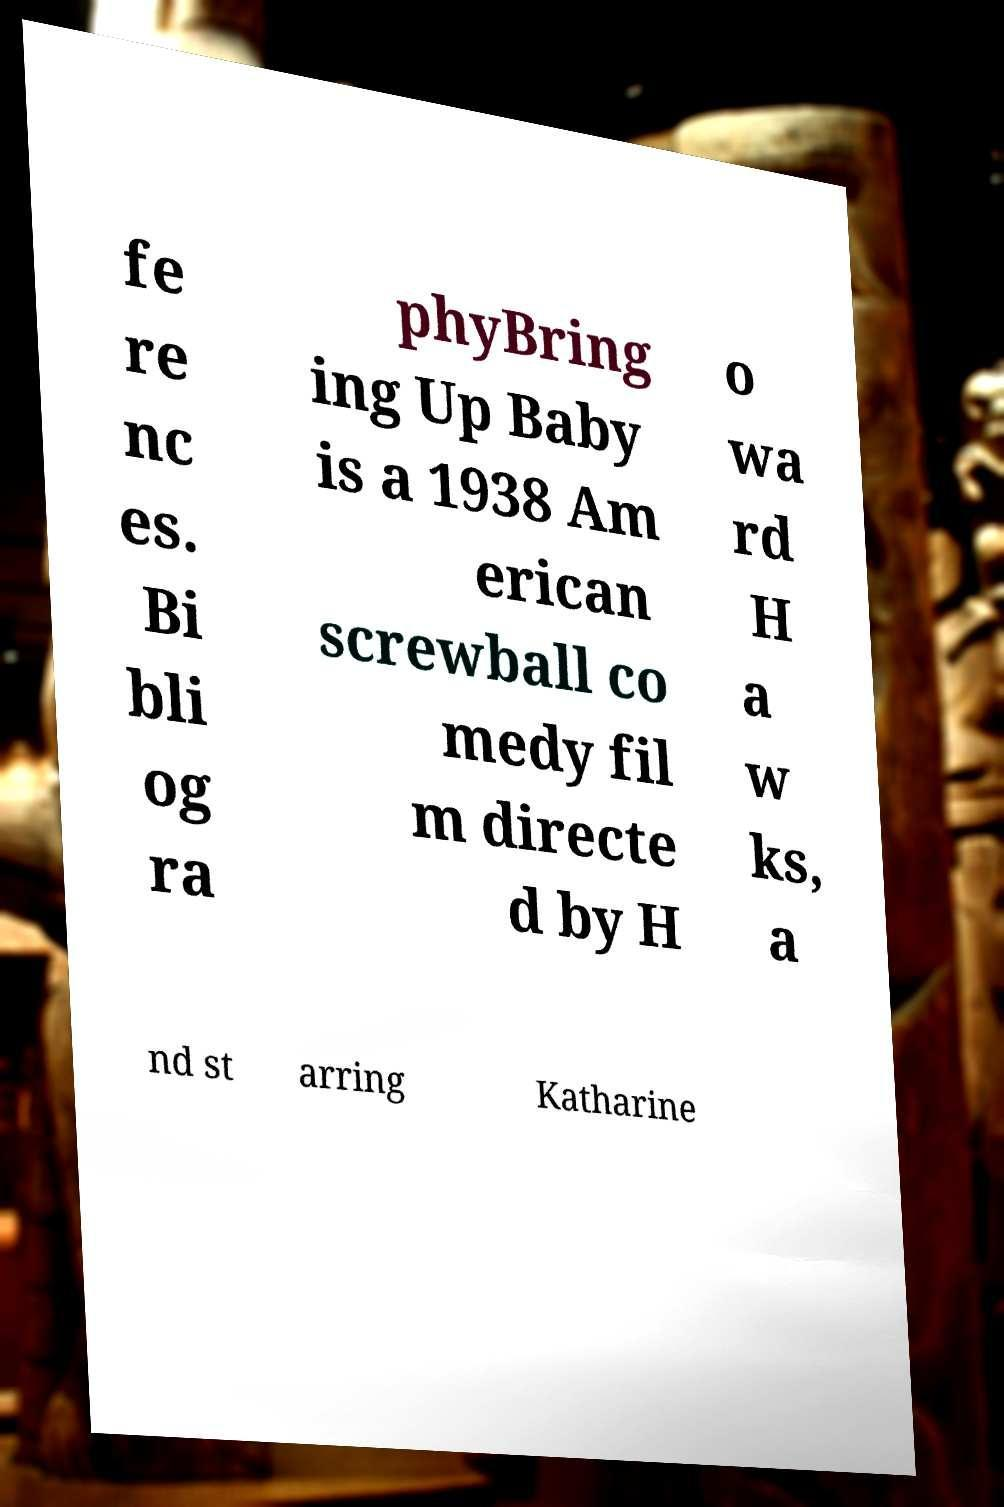Please identify and transcribe the text found in this image. fe re nc es. Bi bli og ra phyBring ing Up Baby is a 1938 Am erican screwball co medy fil m directe d by H o wa rd H a w ks, a nd st arring Katharine 